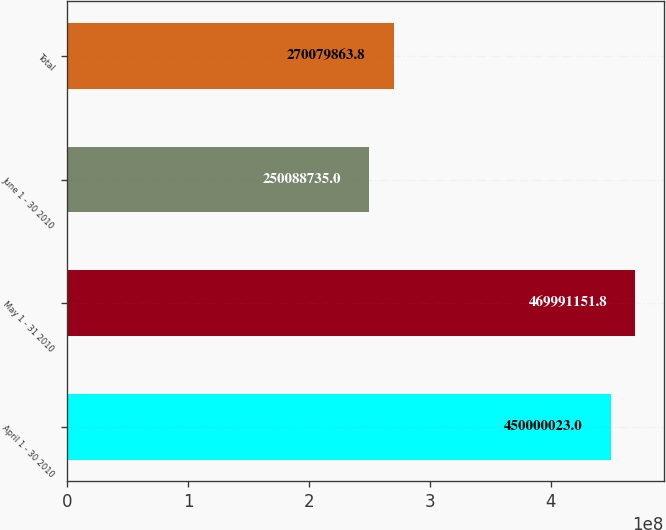<chart> <loc_0><loc_0><loc_500><loc_500><bar_chart><fcel>April 1 - 30 2010<fcel>May 1 - 31 2010<fcel>June 1 - 30 2010<fcel>Total<nl><fcel>4.5e+08<fcel>4.69991e+08<fcel>2.50089e+08<fcel>2.7008e+08<nl></chart> 